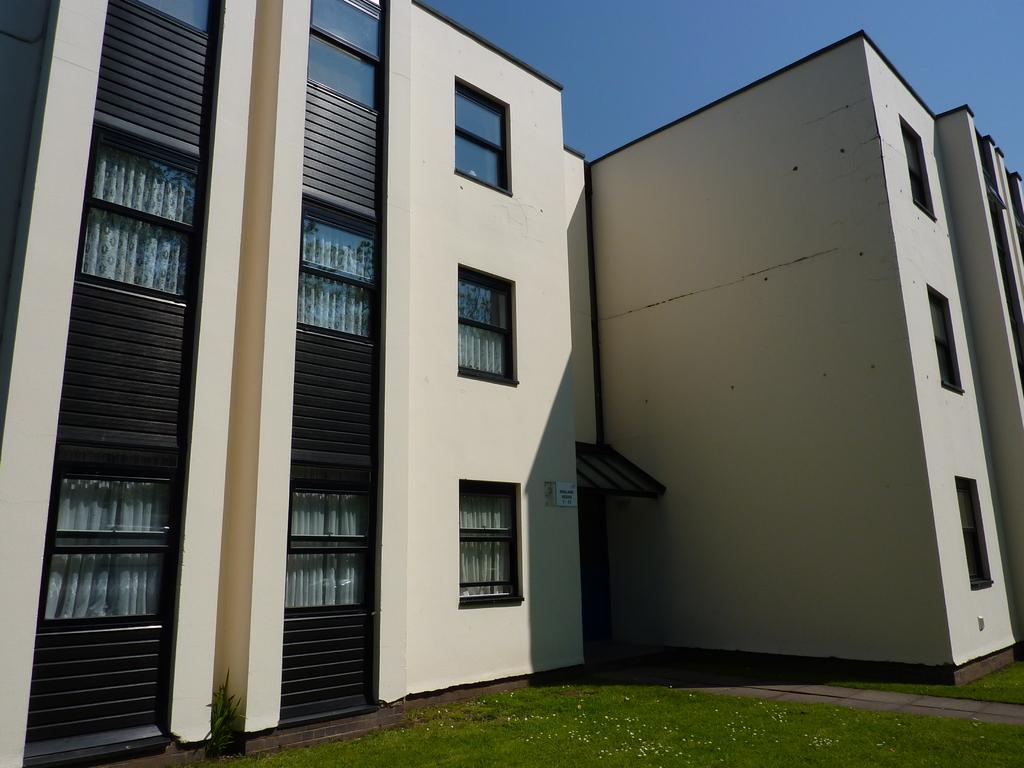What is the color of the building in the image? The building in the image is white-colored. What feature does the building have? The building has windows. What is another object visible in the image? There is a whiteboard in the image. What type of surface is visible in the image? Grass is visible in the image. What else can be seen in the sky? The sky is visible in the image. What is written on the whiteboard? There is writing on the board. What type of gold ornament is hanging from the hill in the image? There is no hill or gold ornament present in the image. 